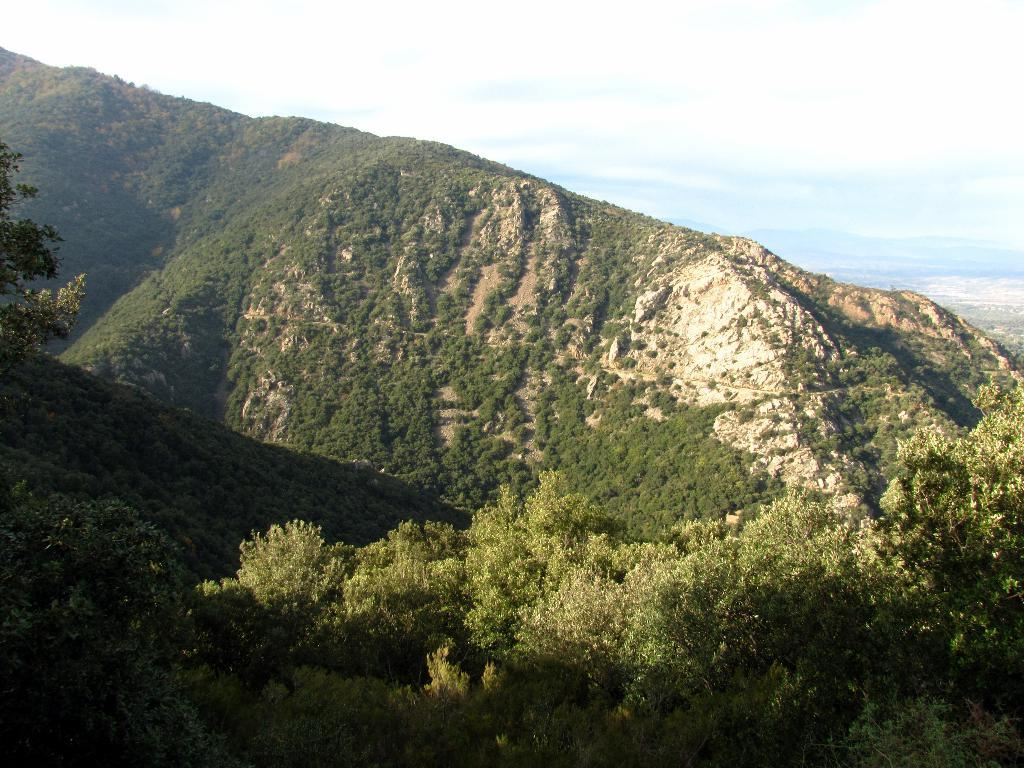What type of vegetation can be seen on the mountains in the foreground of the image? There is greenery on the mountains in the foreground of the image. What can be seen in the background of the image? There is land and mountains visible in the background of the image. What else is visible in the background of the image? The sky is visible in the background of the image. Can you see a rifle hidden in the greenery on the mountains? There is no rifle visible in the image; it only features greenery on the mountains. Are there any rabbits hopping around in the image? There are no rabbits present in the image. 